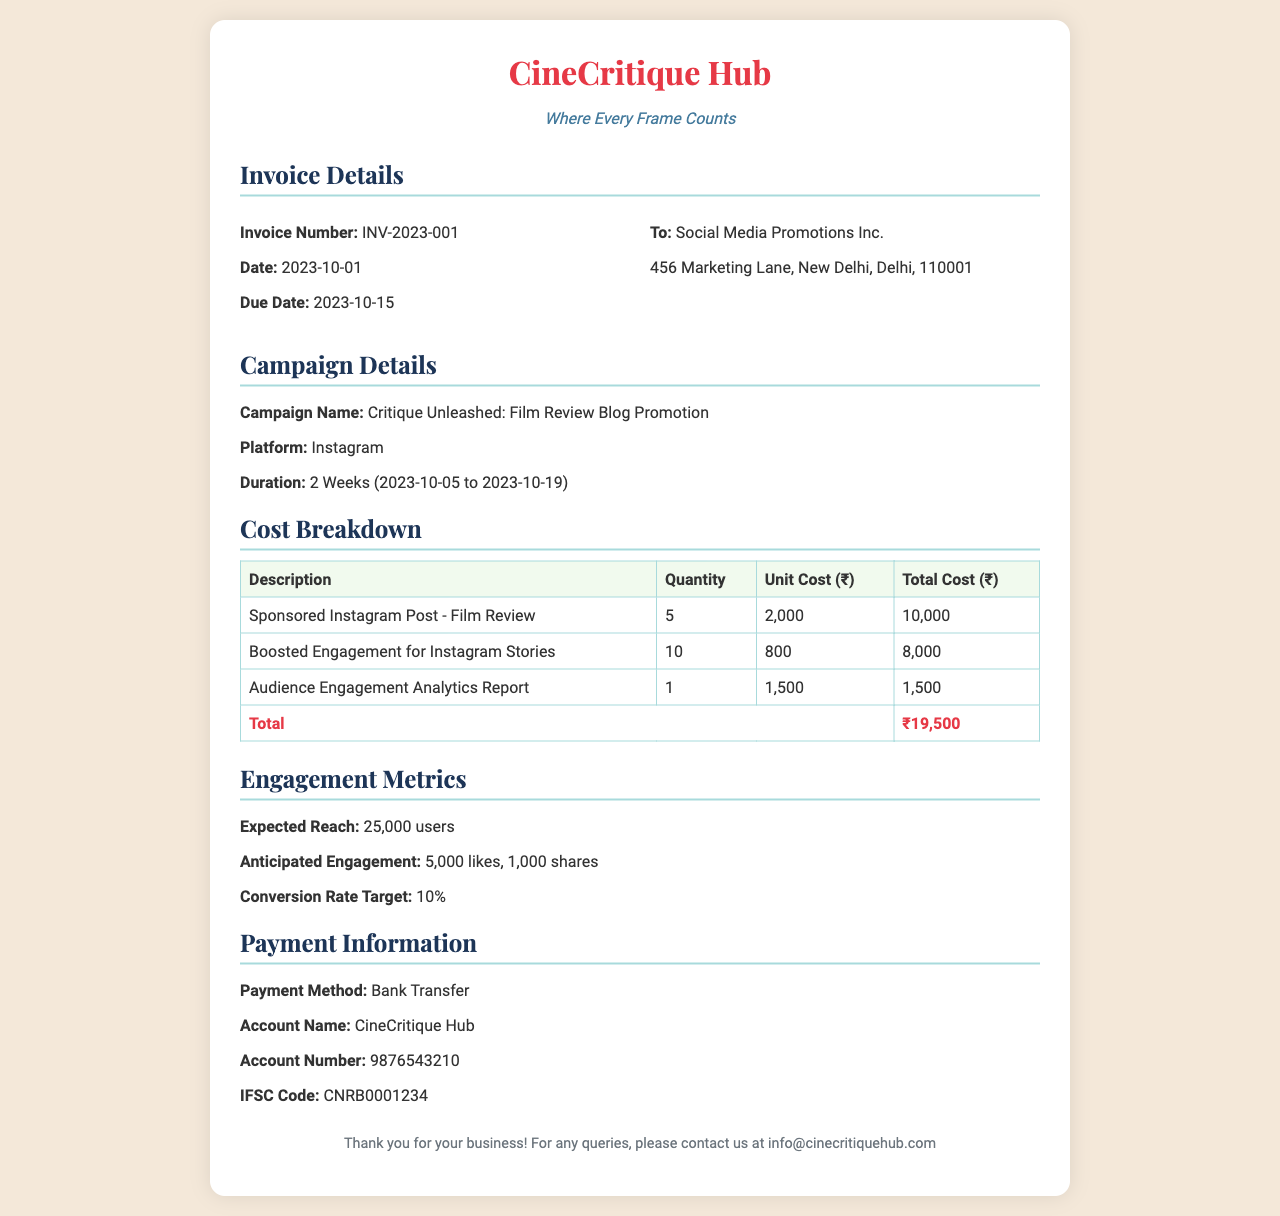What is the invoice number? The invoice number is a unique identifier for this transaction specified in the document.
Answer: INV-2023-001 What is the total cost listed in the invoice? The total cost is the sum of all listed costs for services rendered in the document.
Answer: ₹19,500 What is the Due Date of the invoice? The Due Date indicates when the payment should be made, as highlighted in the document.
Answer: 2023-10-15 What payment method is specified in the document? The payment method is noted in the invoice to guide the client on how to settle the amount.
Answer: Bank Transfer What is the Campaign Name? The Campaign Name describes the purpose of this advertising invoice, providing context for the services.
Answer: Critique Unleashed: Film Review Blog Promotion How many Sponsored Instagram Posts were included in the invoice? The quantity of Sponsored Instagram Posts refers to how many were billed in the service details.
Answer: 5 What is the expected reach of the campaign? The expected reach indicates how many users are anticipated to view the campaign materials as stated in the document.
Answer: 25,000 users What is the duration of the campaign? The duration specifies the time frame within which the campaign activities will take place, as mentioned in the document.
Answer: 2 Weeks (2023-10-05 to 2023-10-19) What is the IFSC code given in the payment information? The IFSC code is essential for making bank transfers, as indicated in the payment section of the document.
Answer: CNRB0001234 